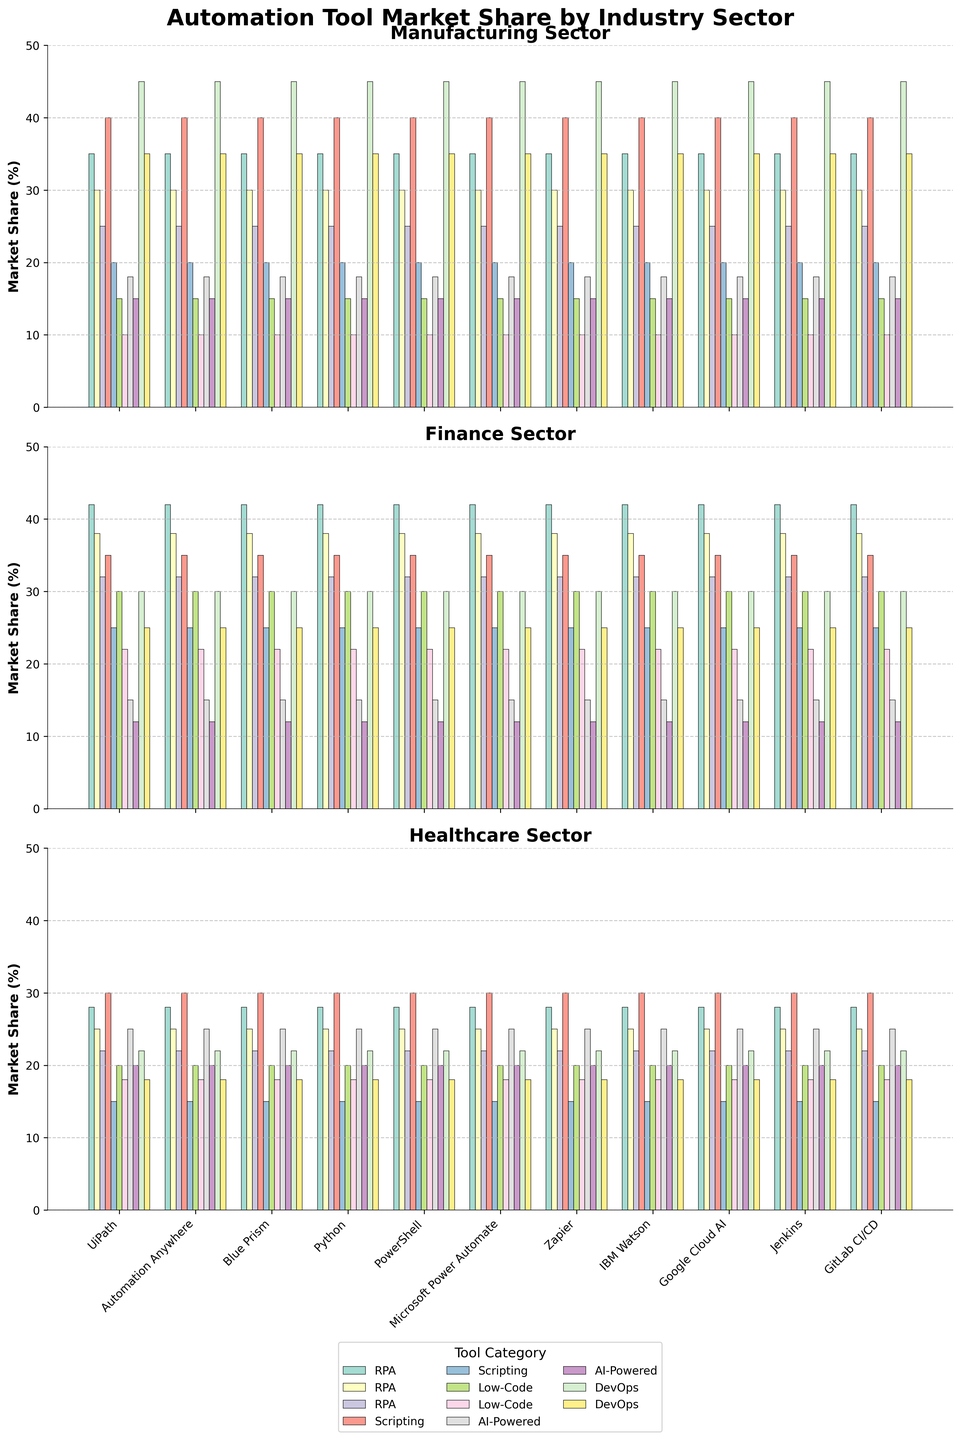What is the title of the figure? The title of the figure can be seen at the top and it reads "Automation Tool Market Share by Industry Sector".
Answer: Automation Tool Market Share by Industry Sector Which industry sector has the highest market share for Jenkins? The subplots for each industry sector show the market share percentages. In the Manufacturing sector subplot, Jenkins has the highest percentage with 45%.
Answer: Manufacturing What is the combined market share of UiPath and Automation Anywhere in the Finance sector? In the Finance sector subplot, the market share for UiPath is 42%, and for Automation Anywhere it is 38%. The combined market share is 42 + 38 = 80%.
Answer: 80% How does the market share of Python compare across Manufacturing, Finance, and Healthcare sectors? The plot bar heights for Python in each subplot show different percentages. In the Manufacturing sector, Python has 40%, in Finance, it has 35%, and in Healthcare, it has 30%.
Answer: Manufacturing > Finance > Healthcare Which automation tool category has the lowest market share in the Healthcare sector? In the Healthcare sector subplot, the lowest bar corresponds to PowerShell in the Scripting category with a market share of 15%.
Answer: PowerShell What is the average market share for Low-Code tools in the Manufacturing sector? In the Manufacturing sector subplot, the market shares for Low-Code tools (Microsoft Power Automate and Zapier) are 15% and 10%. The average is (15 + 10) / 2 = 12.5%.
Answer: 12.5% Which industry sector shows the highest market share for DevOps tools overall? By visually comparing the bar heights for DevOps tools (Jenkins and GitLab CI/CD) across all industry sector subplots, the Manufacturing sector shows the highest combined percentages for Jenkins (45%) and GitLab CI/CD (35%), totaling 80%.
Answer: Manufacturing What is the difference in market share of IBM Watson between Healthcare and Manufacturing sectors? The subplot for Healthcare shows IBM Watson with a market share of 25%, while in the Manufacturing sector, it is 18%. The difference is 25 - 18 = 7%.
Answer: 7% How many automation tool categories are represented in the subplots? Each subplot shows bars for distinct categories: RPA, Scripting, Low-Code, AI-Powered, and DevOps, totaling 5 categories.
Answer: 5 